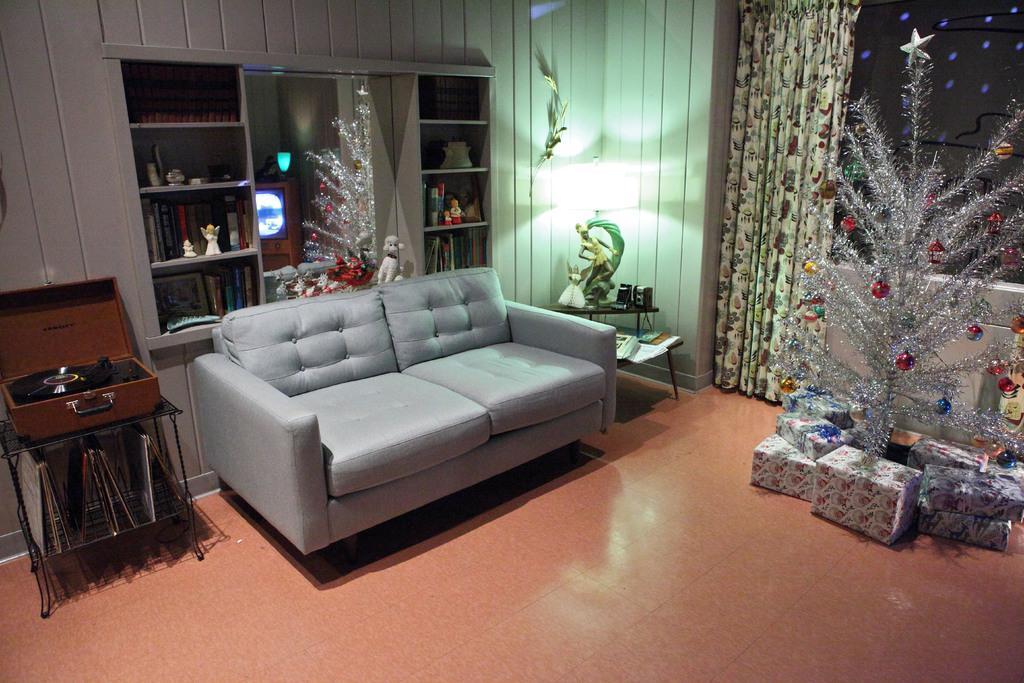Please provide a concise description of this image. In the picture we can see a house hall, in a hall there is a sofa near to it there is a table on it there is a suitcase opened and there is a CD in it, to the right hand side of sofa there is another table and something kept on it, just behind the sofa we can see a shelves and some decorative items are kept in it, and we can also see a wall, window, which is covered with curtain and there is a decorated tree. 